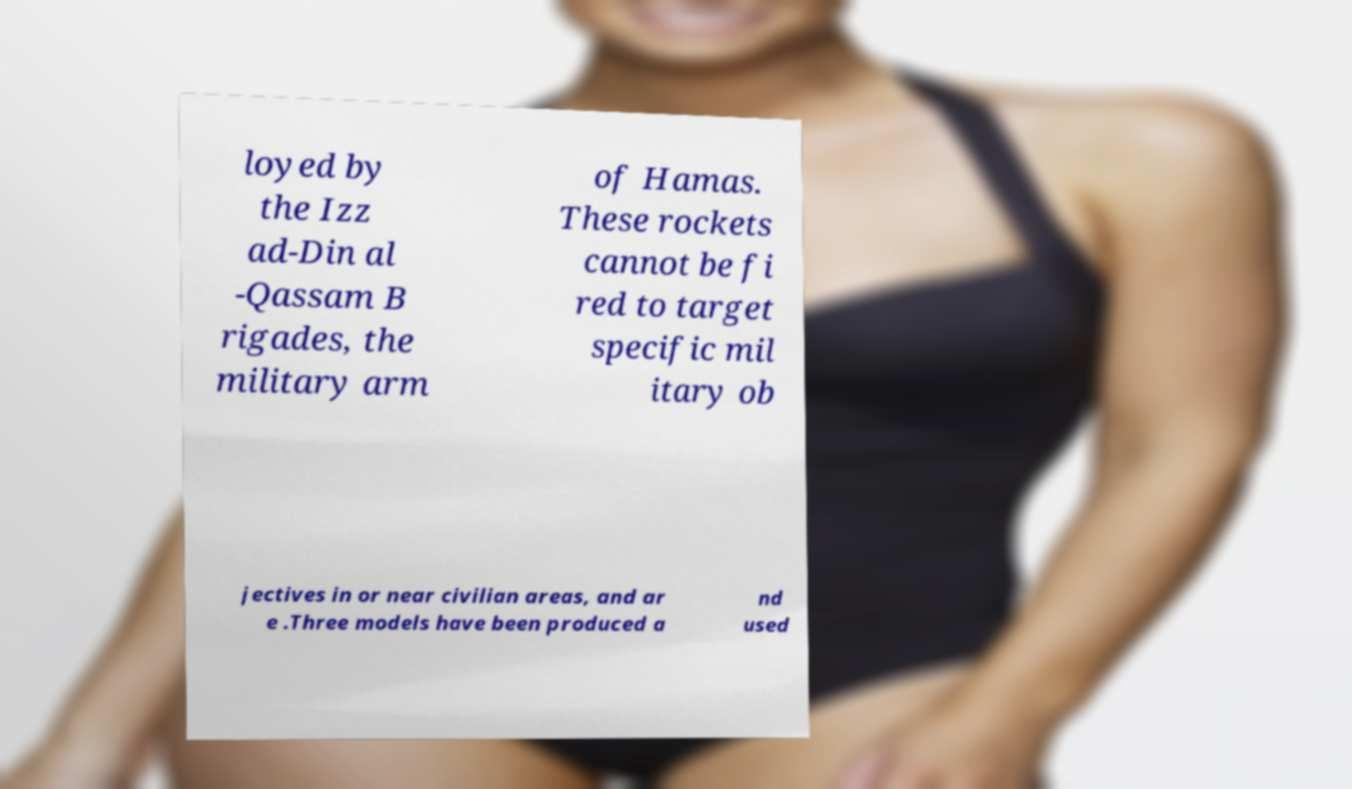For documentation purposes, I need the text within this image transcribed. Could you provide that? loyed by the Izz ad-Din al -Qassam B rigades, the military arm of Hamas. These rockets cannot be fi red to target specific mil itary ob jectives in or near civilian areas, and ar e .Three models have been produced a nd used 